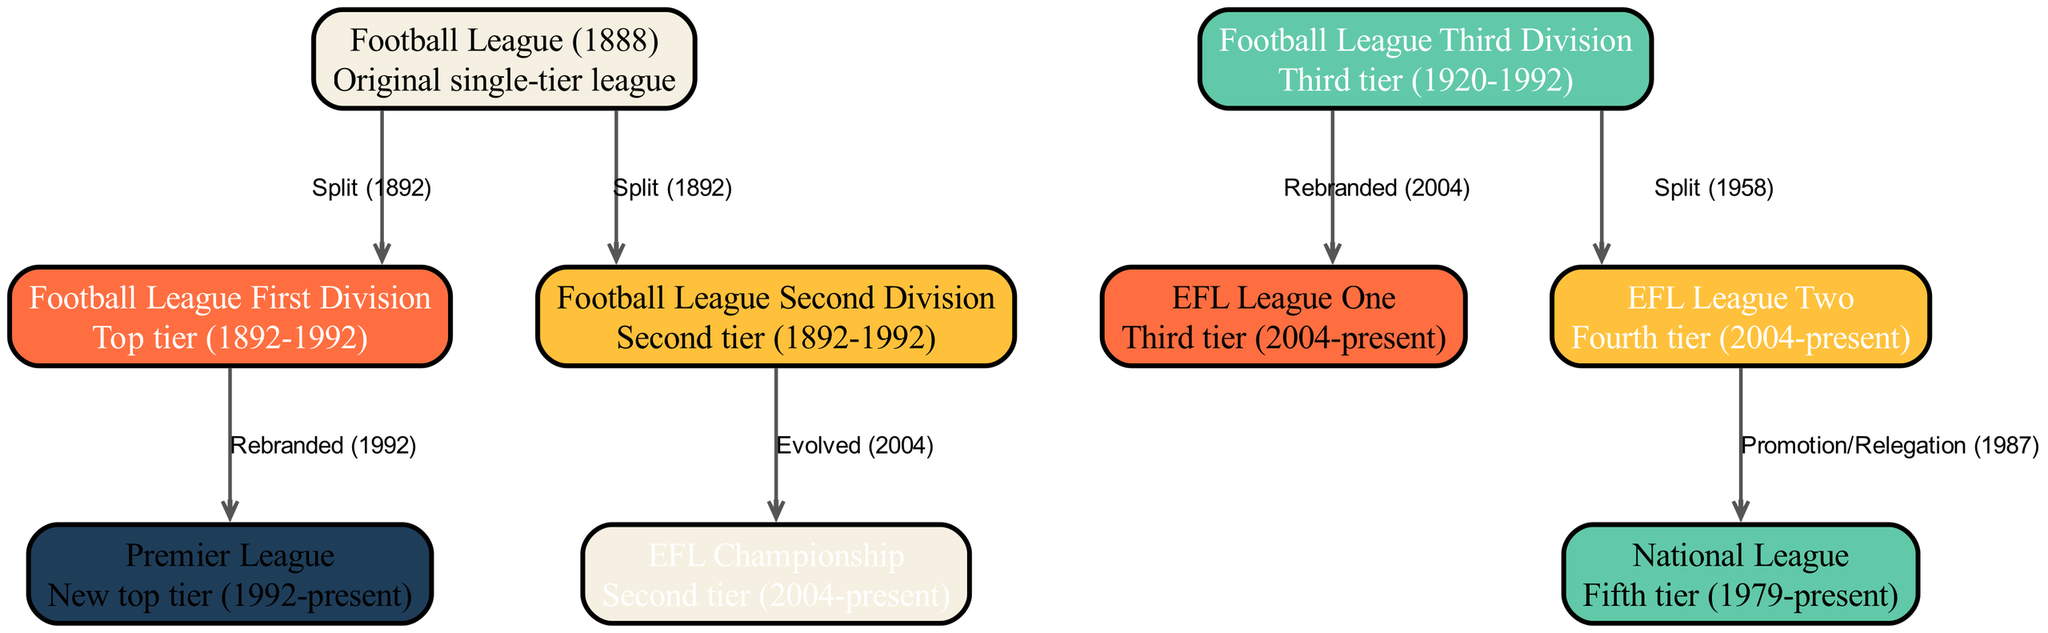What is the top tier of the football pyramid as of 2023? The diagram indicates that the Premier League is the top tier since its establishment in 1992 and is marked as the current highest level in the league system.
Answer: Premier League How many nodes are present in the diagram? By counting the nodes listed in the data, there are 9 distinct entities representing different leagues or divisions in the football pyramid, therefore the total count is 9.
Answer: 9 What labels connect the Football League and the Football League First Division? The diagram shows a direct connection labeled "Split (1892)" between the Football League and the Football League First Division, indicating that this was the year the first division separated from the original structure.
Answer: Split (1892) Which division evolved into the EFL Championship? The Football League Second Division is indicated as having evolved into the EFL Championship in 2004, representing a transformation in the tier structure.
Answer: Football League Second Division What is the relationship between EFL League Two and the National League? The diagram illustrates that there is a promotional relationship from EFL League Two to the National League that was established through "Promotion/Relegation (1987)," indicating movement between these tiers based on performance.
Answer: Promotion/Relegation (1987) Which division was rebranded in 2004? Both the Football League Third Division and the Football League Second Division underwent a rebranding process in 2004, aligning them under new titles, EFL League One and EFL Championship, respectively.
Answer: Football League Third Division What significant change occurred to the Football League First Division in 1992? The relationship between the Football League First Division and the Premier League indicates that the First Division was rebranded in 1992 to become what is now known as the Premier League, marking a major historical shift in English football.
Answer: Rebranded (1992) What year was the National League established? The National League is noted to have been established in 1979, representing the fifth tier of the English football pyramid as defined in the diagram.
Answer: 1979 How are the Football League Third Division and EFL League One connected? The diagram specifies that the Football League Third Division evolved into EFL League One in 2004, illustrating a clear progression in the football league structure at that time.
Answer: Evolved (2004) 